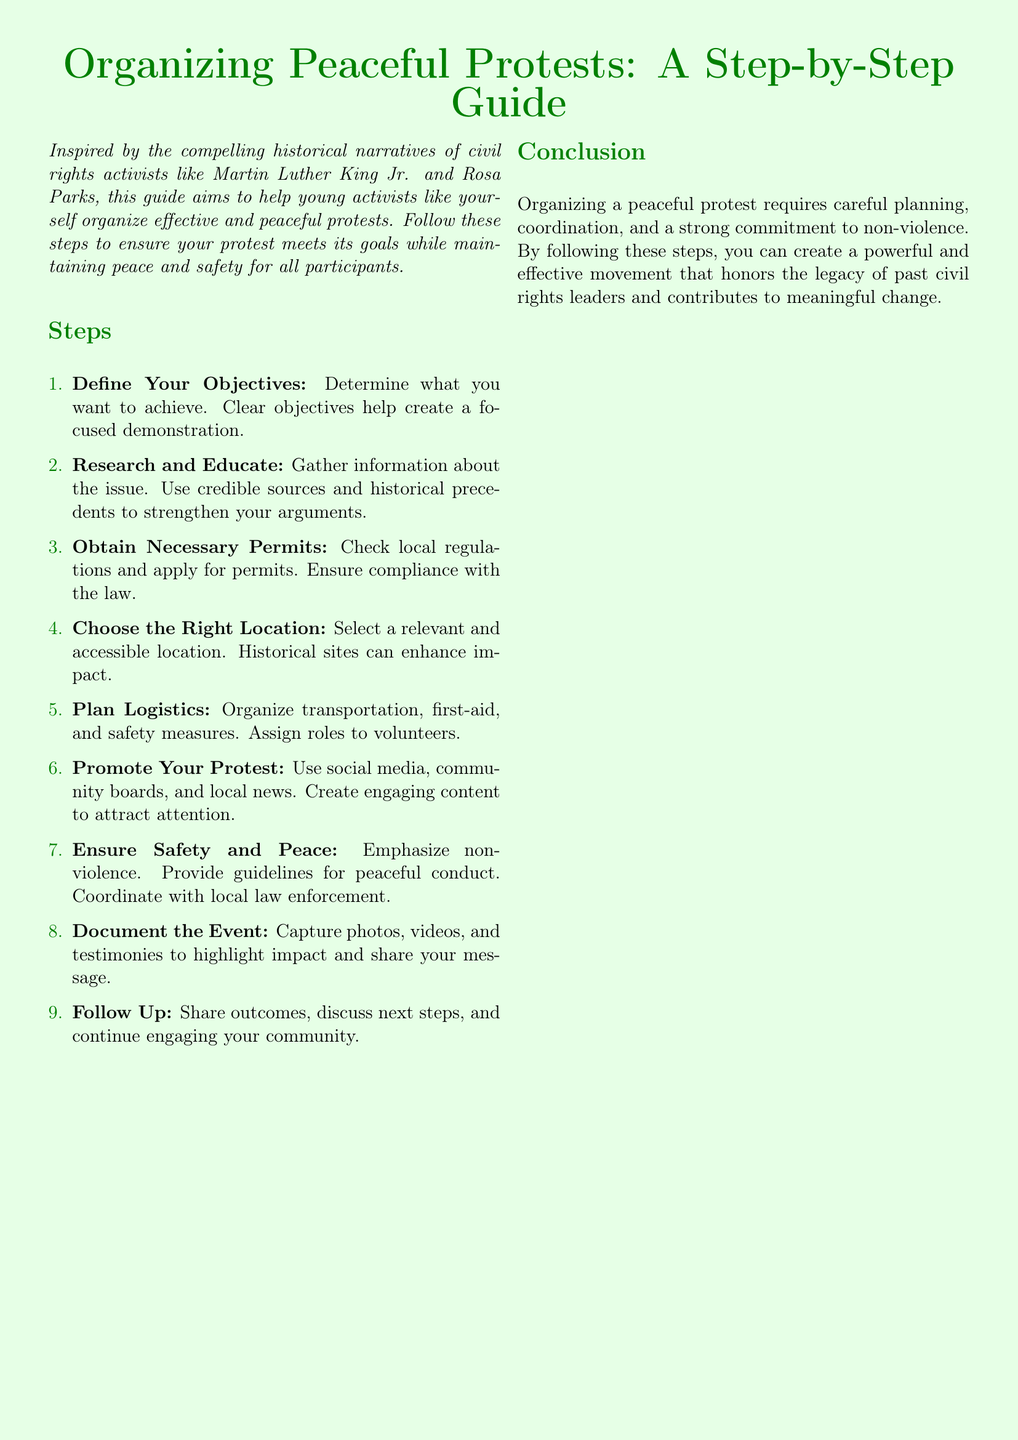what is the title of the guide? The title of the guide is the first line in the document, which outlines the purpose of the document.
Answer: Organizing Peaceful Protests: A Step-by-Step Guide how many steps are listed in the guide? The number of steps is indicated by the countable items in the list provided in the document.
Answer: 9 what should you do to ensure compliance with the law? This question is about legal requirements mentioned in the document.
Answer: Obtain Necessary Permits what is emphasized for the safety of the protest? This question pertains to the values that need to be prioritized to ensure peaceful conduct.
Answer: Non-violence which historical figures inspired this guide? This question asks for the specific names mentioned in the introductory text that inspired the guide.
Answer: Martin Luther King Jr. and Rosa Parks what is the first step in organizing a protest? This question relates to the sequence of actions required as outlined in the document.
Answer: Define Your Objectives how should you promote your protest? This question asks for the method suggested in the guide for attracting attention to the protest.
Answer: Use social media what is the last action mentioned in the steps? This question refers to the conclusion of the steps listed in the document.
Answer: Follow Up what is the overall focus of this guide? This question queries the main purpose or goal of the document as described in the conclusion.
Answer: Peaceful protest organization 